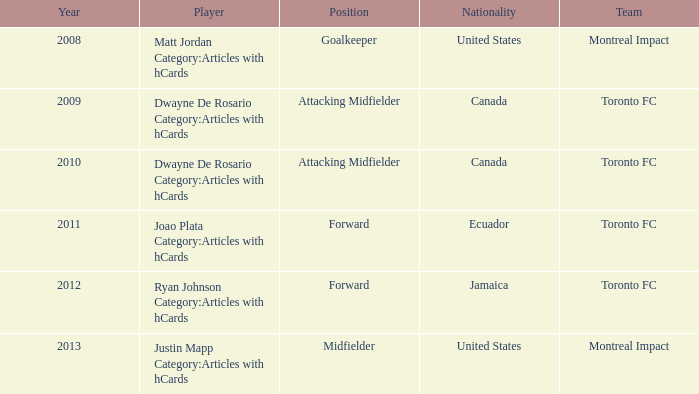What's the nationality of Montreal Impact with Justin Mapp Category:articles with hcards as the player? United States. 